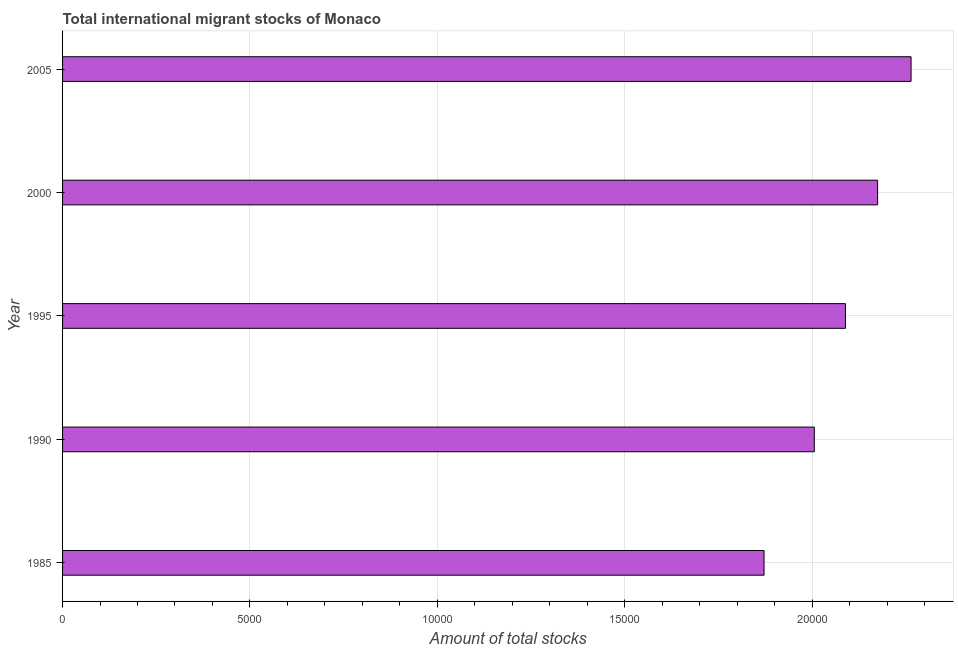What is the title of the graph?
Offer a terse response. Total international migrant stocks of Monaco. What is the label or title of the X-axis?
Your answer should be very brief. Amount of total stocks. What is the label or title of the Y-axis?
Ensure brevity in your answer.  Year. What is the total number of international migrant stock in 1990?
Offer a terse response. 2.01e+04. Across all years, what is the maximum total number of international migrant stock?
Keep it short and to the point. 2.26e+04. Across all years, what is the minimum total number of international migrant stock?
Keep it short and to the point. 1.87e+04. In which year was the total number of international migrant stock maximum?
Give a very brief answer. 2005. In which year was the total number of international migrant stock minimum?
Provide a succinct answer. 1985. What is the sum of the total number of international migrant stock?
Your answer should be very brief. 1.04e+05. What is the difference between the total number of international migrant stock in 2000 and 2005?
Offer a very short reply. -893. What is the average total number of international migrant stock per year?
Ensure brevity in your answer.  2.08e+04. What is the median total number of international migrant stock?
Make the answer very short. 2.09e+04. In how many years, is the total number of international migrant stock greater than 22000 ?
Make the answer very short. 1. Do a majority of the years between 2000 and 1995 (inclusive) have total number of international migrant stock greater than 9000 ?
Keep it short and to the point. No. What is the ratio of the total number of international migrant stock in 1990 to that in 1995?
Your answer should be compact. 0.96. Is the total number of international migrant stock in 1995 less than that in 2005?
Make the answer very short. Yes. What is the difference between the highest and the second highest total number of international migrant stock?
Your response must be concise. 893. What is the difference between the highest and the lowest total number of international migrant stock?
Offer a very short reply. 3923. In how many years, is the total number of international migrant stock greater than the average total number of international migrant stock taken over all years?
Provide a short and direct response. 3. How many bars are there?
Your response must be concise. 5. Are all the bars in the graph horizontal?
Your response must be concise. Yes. How many years are there in the graph?
Offer a very short reply. 5. What is the difference between two consecutive major ticks on the X-axis?
Your answer should be very brief. 5000. What is the Amount of total stocks of 1985?
Provide a succinct answer. 1.87e+04. What is the Amount of total stocks in 1990?
Provide a succinct answer. 2.01e+04. What is the Amount of total stocks of 1995?
Your answer should be compact. 2.09e+04. What is the Amount of total stocks in 2000?
Offer a very short reply. 2.17e+04. What is the Amount of total stocks of 2005?
Provide a short and direct response. 2.26e+04. What is the difference between the Amount of total stocks in 1985 and 1990?
Keep it short and to the point. -1341. What is the difference between the Amount of total stocks in 1985 and 1995?
Keep it short and to the point. -2172. What is the difference between the Amount of total stocks in 1985 and 2000?
Your response must be concise. -3030. What is the difference between the Amount of total stocks in 1985 and 2005?
Keep it short and to the point. -3923. What is the difference between the Amount of total stocks in 1990 and 1995?
Offer a very short reply. -831. What is the difference between the Amount of total stocks in 1990 and 2000?
Make the answer very short. -1689. What is the difference between the Amount of total stocks in 1990 and 2005?
Ensure brevity in your answer.  -2582. What is the difference between the Amount of total stocks in 1995 and 2000?
Your answer should be compact. -858. What is the difference between the Amount of total stocks in 1995 and 2005?
Make the answer very short. -1751. What is the difference between the Amount of total stocks in 2000 and 2005?
Your response must be concise. -893. What is the ratio of the Amount of total stocks in 1985 to that in 1990?
Your answer should be compact. 0.93. What is the ratio of the Amount of total stocks in 1985 to that in 1995?
Offer a very short reply. 0.9. What is the ratio of the Amount of total stocks in 1985 to that in 2000?
Your response must be concise. 0.86. What is the ratio of the Amount of total stocks in 1985 to that in 2005?
Keep it short and to the point. 0.83. What is the ratio of the Amount of total stocks in 1990 to that in 2000?
Offer a very short reply. 0.92. What is the ratio of the Amount of total stocks in 1990 to that in 2005?
Offer a terse response. 0.89. What is the ratio of the Amount of total stocks in 1995 to that in 2000?
Give a very brief answer. 0.96. What is the ratio of the Amount of total stocks in 1995 to that in 2005?
Give a very brief answer. 0.92. What is the ratio of the Amount of total stocks in 2000 to that in 2005?
Make the answer very short. 0.96. 